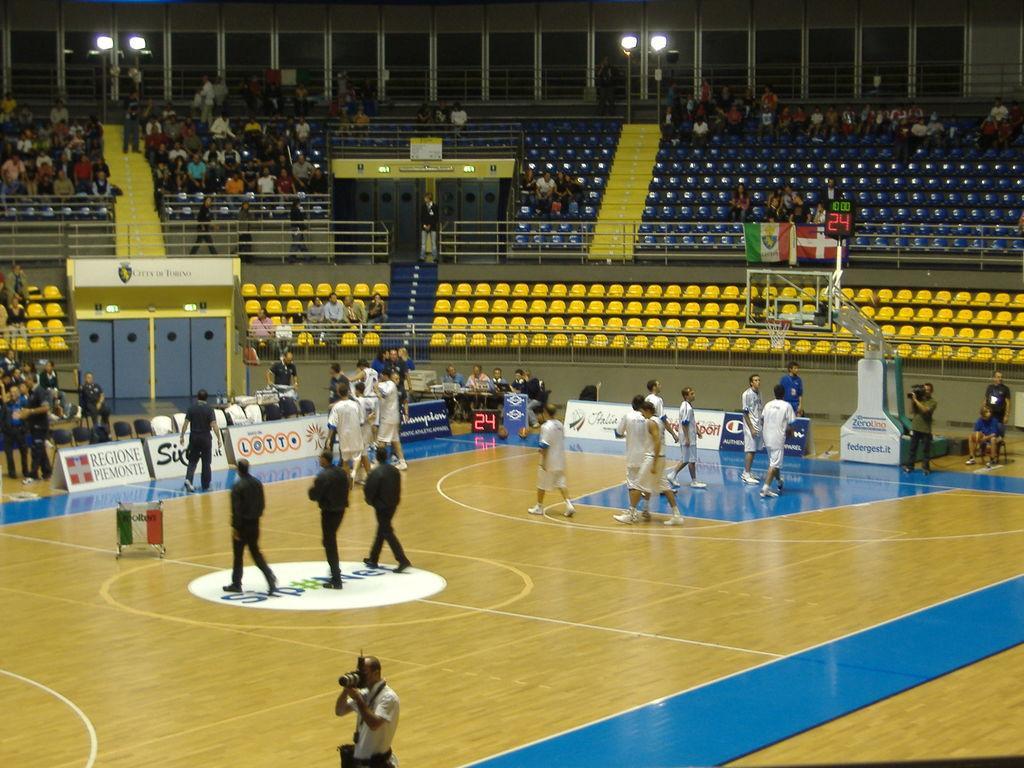In one or two sentences, can you explain what this image depicts? In this picture we can see basketball court. Here we can see players who are wearing white dress. In the center of the court we can see three persons wearing black dress. On the top left corner we can see audience was sitting on the chair and watching the game. Here we can see fencing and stairs near to the entrance. At the top we can see lights and windows. On the left there is a man who is holding camera. Here we can see timer. On the bottom we can see another man who is holding a camera. 